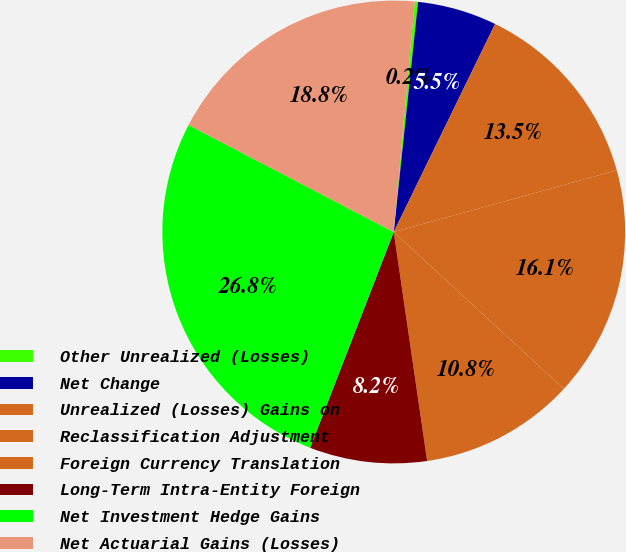Convert chart to OTSL. <chart><loc_0><loc_0><loc_500><loc_500><pie_chart><fcel>Other Unrealized (Losses)<fcel>Net Change<fcel>Unrealized (Losses) Gains on<fcel>Reclassification Adjustment<fcel>Foreign Currency Translation<fcel>Long-Term Intra-Entity Foreign<fcel>Net Investment Hedge Gains<fcel>Net Actuarial Gains (Losses)<nl><fcel>0.23%<fcel>5.54%<fcel>13.49%<fcel>16.15%<fcel>10.84%<fcel>8.19%<fcel>26.76%<fcel>18.8%<nl></chart> 